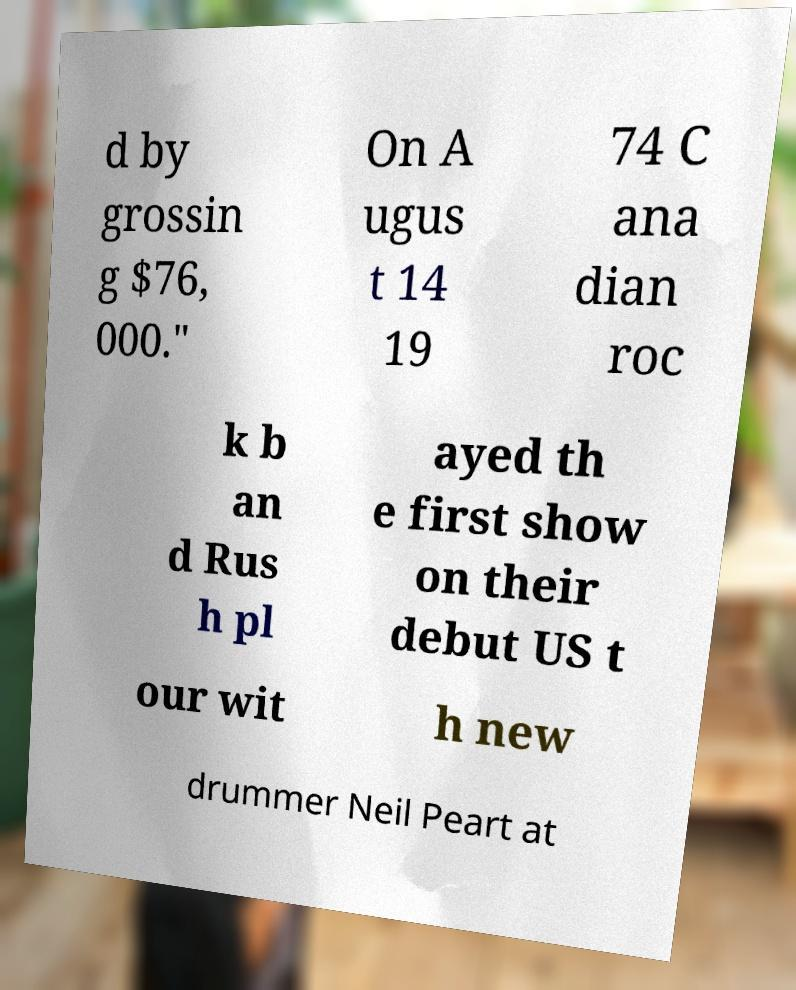Please identify and transcribe the text found in this image. d by grossin g $76, 000." On A ugus t 14 19 74 C ana dian roc k b an d Rus h pl ayed th e first show on their debut US t our wit h new drummer Neil Peart at 